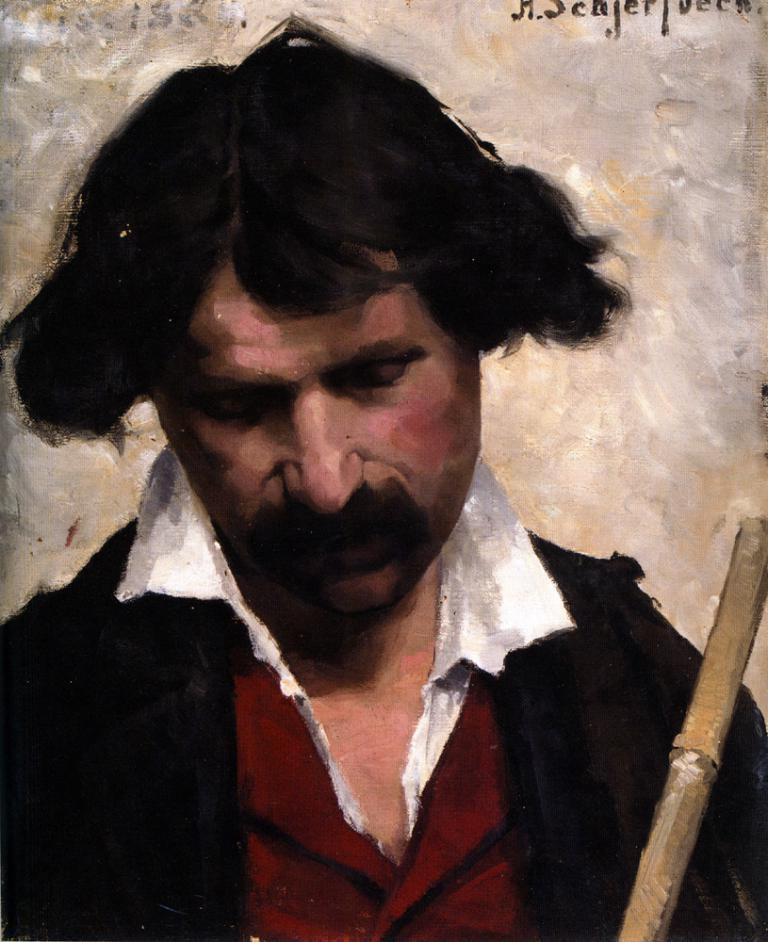How would you summarize this image in a sentence or two? In this image, we can see painting of a man wearing a black color shirt. In the right corner, we can also see a stick. In the background, we can also see white color. 